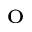<formula> <loc_0><loc_0><loc_500><loc_500>^ { o }</formula> 